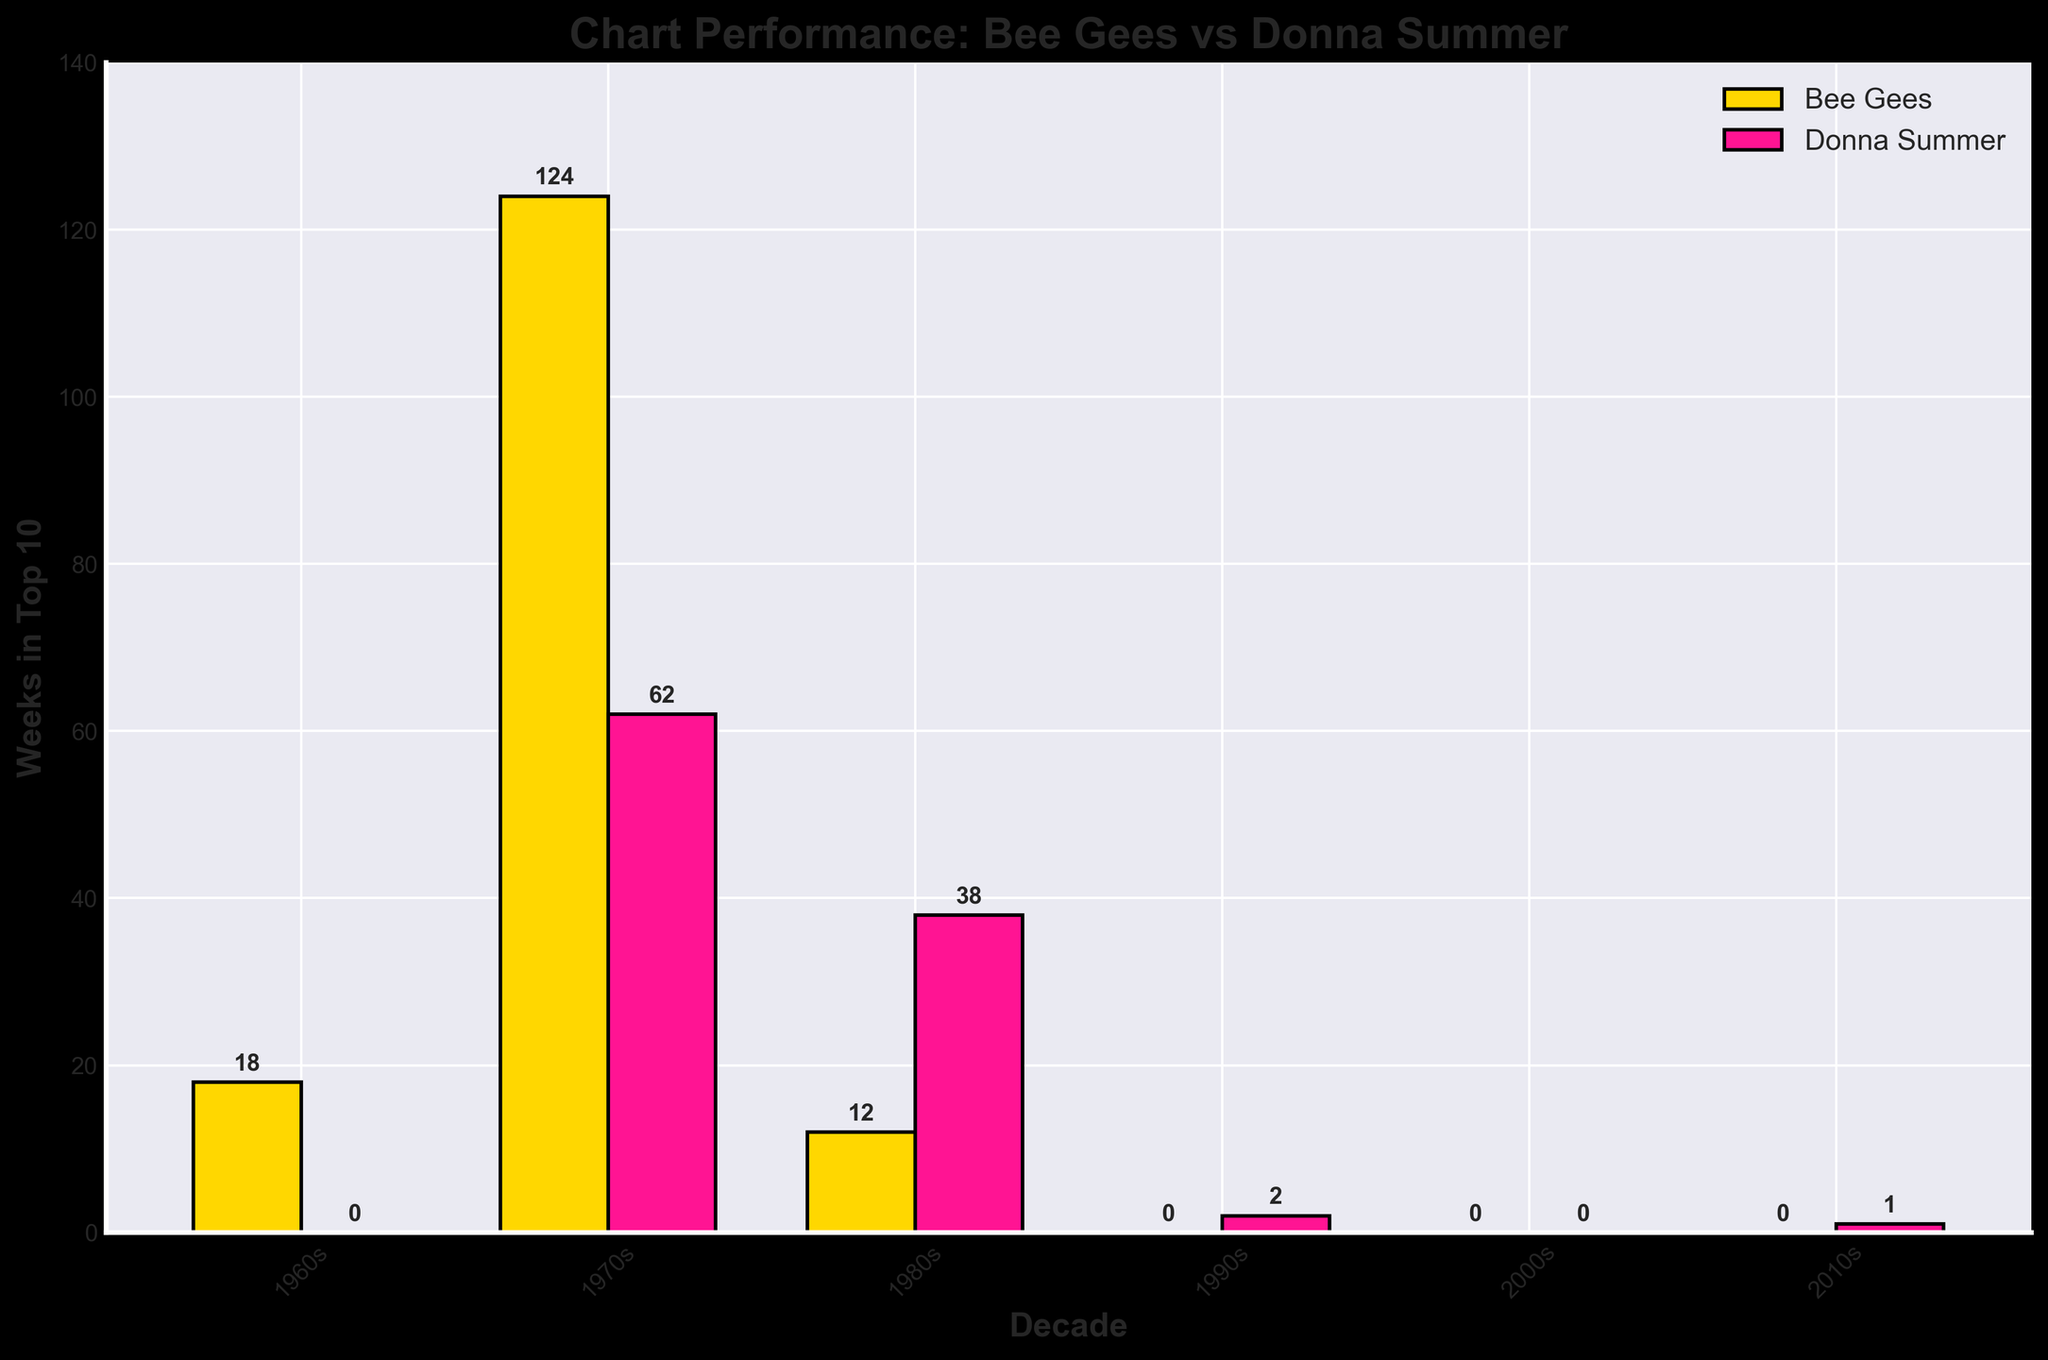Which decade did the Bee Gees spend the most weeks in the top 10? From the chart, the bar for the Bee Gees is the highest in the 1970s, indicating they spent the most weeks in the top 10 during that decade.
Answer: 1970s How many more weeks did Donna Summer spend in the top 10 in the 1970s compared to the 1980s? In the 1970s, Donna Summer spent 62 weeks in the top 10, while in the 1980s, she spent 38 weeks. The difference is 62 - 38 = 24 weeks.
Answer: 24 weeks What is the total number of weeks the Bee Gees spent in the top 10 across all decades? Sum the total weeks for Bee Gees: 18 (1960s) + 124 (1970s) + 12 (1980s) + 0 (1990s) + 0 (2000s) + 0 (2010s) = 154 weeks.
Answer: 154 weeks Which artist had more weeks in the top 10 during the 2010s? From the chart, Donna Summer is the only artist with weeks in the top 10 during the 2010s, with 1 week. The Bee Gees have 0 weeks.
Answer: Donna Summer In which decade did both artists have zero weeks in the top 10? According to the chart, both the Bee Gees and Donna Summer have zero weeks in the top 10 in the 2000s.
Answer: 2000s By how many weeks did the Bee Gees outperform Donna Summer in the 1970s? In the 1970s, the Bee Gees spent 124 weeks in the top 10 while Donna Summer spent 62 weeks. The difference is 124 - 62 = 62 weeks.
Answer: 62 weeks What is the median number of weeks spent in the top 10 for Donna Summer across all decades? The weeks are 0 (1960s), 62 (1970s), 38 (1980s), 2 (1990s), 0 (2000s), and 1 (2010s). Ordering these gives: 0, 0, 1, 2, 38, 62. The median is the average of the two middle values: (1 + 2) / 2 = 1.5 weeks.
Answer: 1.5 weeks Which decade saw the least chart presence for the Bee Gees? The Bee Gees have no chart presence in the 1990s, 2000s, and 2010s. The earliest of these is the 1990s.
Answer: 1990s Compare the total number of weeks spent in the top 10 for both artists combined in the 1980s. In the 1980s, the Bee Gees spent 12 weeks and Donna Summer spent 38 weeks. The total is 12 + 38 = 50 weeks.
Answer: 50 weeks 